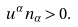<formula> <loc_0><loc_0><loc_500><loc_500>u ^ { \alpha } n _ { \alpha } > 0 .</formula> 